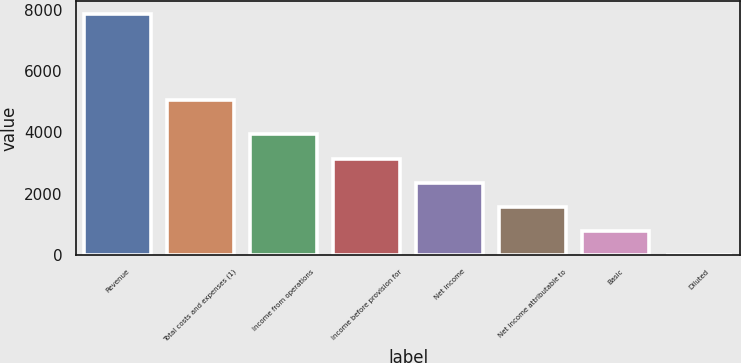Convert chart. <chart><loc_0><loc_0><loc_500><loc_500><bar_chart><fcel>Revenue<fcel>Total costs and expenses (1)<fcel>Income from operations<fcel>Income before provision for<fcel>Net income<fcel>Net income attributable to<fcel>Basic<fcel>Diluted<nl><fcel>7872<fcel>5068<fcel>3936.3<fcel>3149.16<fcel>2362.02<fcel>1574.88<fcel>787.74<fcel>0.6<nl></chart> 